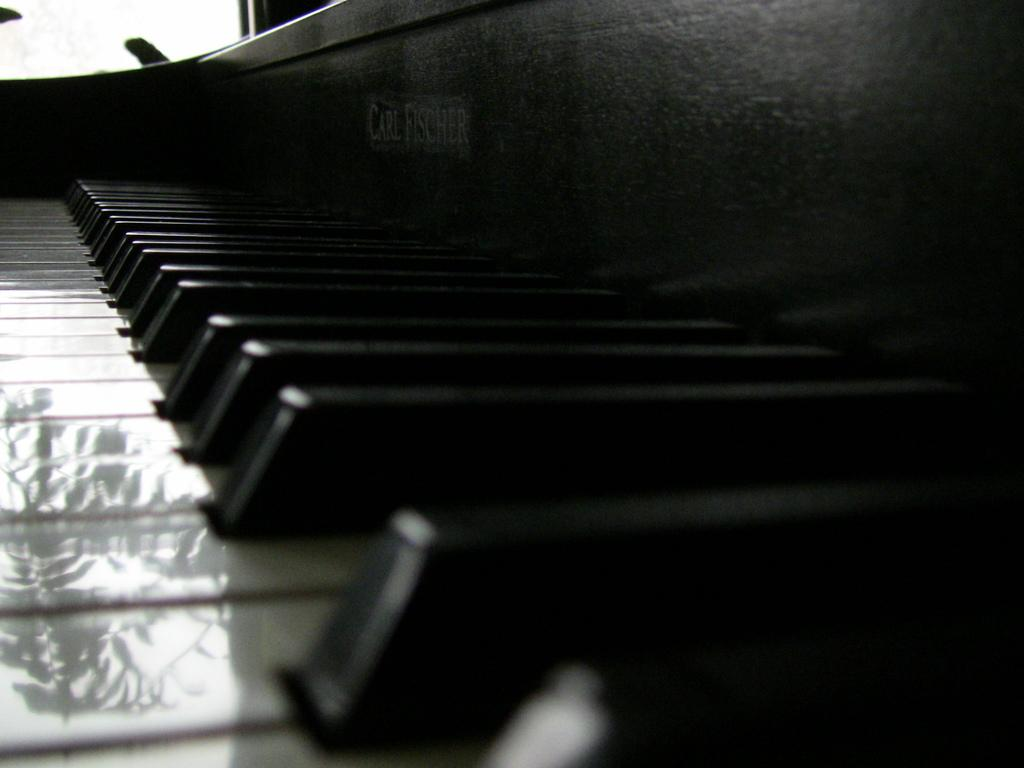What is the main object in the image? There is a piano in the image. What type of musical instrument is the piano? The piano is a keyboard instrument that produces sound by striking strings with hammers when keys are pressed. What might someone be doing with the piano in the image? Someone might be playing the piano, practicing, or simply admiring it. What type of game is being played on the piano in the image? There is no game being played on the piano in the image; it is a musical instrument used for creating music. 